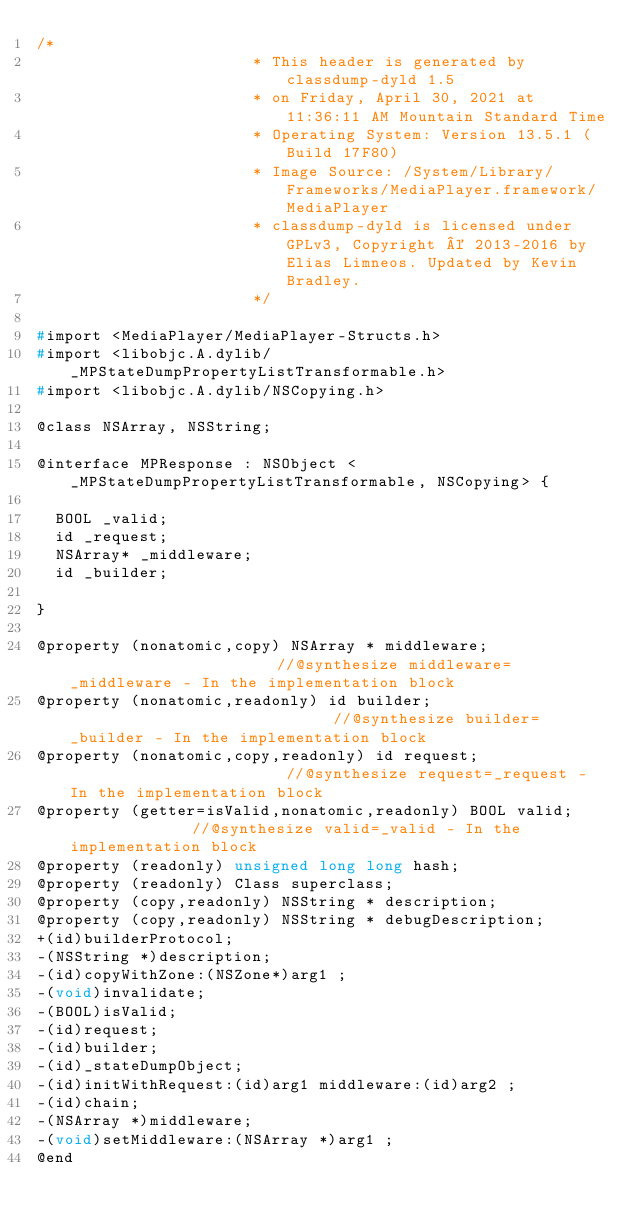<code> <loc_0><loc_0><loc_500><loc_500><_C_>/*
                       * This header is generated by classdump-dyld 1.5
                       * on Friday, April 30, 2021 at 11:36:11 AM Mountain Standard Time
                       * Operating System: Version 13.5.1 (Build 17F80)
                       * Image Source: /System/Library/Frameworks/MediaPlayer.framework/MediaPlayer
                       * classdump-dyld is licensed under GPLv3, Copyright © 2013-2016 by Elias Limneos. Updated by Kevin Bradley.
                       */

#import <MediaPlayer/MediaPlayer-Structs.h>
#import <libobjc.A.dylib/_MPStateDumpPropertyListTransformable.h>
#import <libobjc.A.dylib/NSCopying.h>

@class NSArray, NSString;

@interface MPResponse : NSObject <_MPStateDumpPropertyListTransformable, NSCopying> {

	BOOL _valid;
	id _request;
	NSArray* _middleware;
	id _builder;

}

@property (nonatomic,copy) NSArray * middleware;                       //@synthesize middleware=_middleware - In the implementation block
@property (nonatomic,readonly) id builder;                             //@synthesize builder=_builder - In the implementation block
@property (nonatomic,copy,readonly) id request;                        //@synthesize request=_request - In the implementation block
@property (getter=isValid,nonatomic,readonly) BOOL valid;              //@synthesize valid=_valid - In the implementation block
@property (readonly) unsigned long long hash; 
@property (readonly) Class superclass; 
@property (copy,readonly) NSString * description; 
@property (copy,readonly) NSString * debugDescription; 
+(id)builderProtocol;
-(NSString *)description;
-(id)copyWithZone:(NSZone*)arg1 ;
-(void)invalidate;
-(BOOL)isValid;
-(id)request;
-(id)builder;
-(id)_stateDumpObject;
-(id)initWithRequest:(id)arg1 middleware:(id)arg2 ;
-(id)chain;
-(NSArray *)middleware;
-(void)setMiddleware:(NSArray *)arg1 ;
@end

</code> 